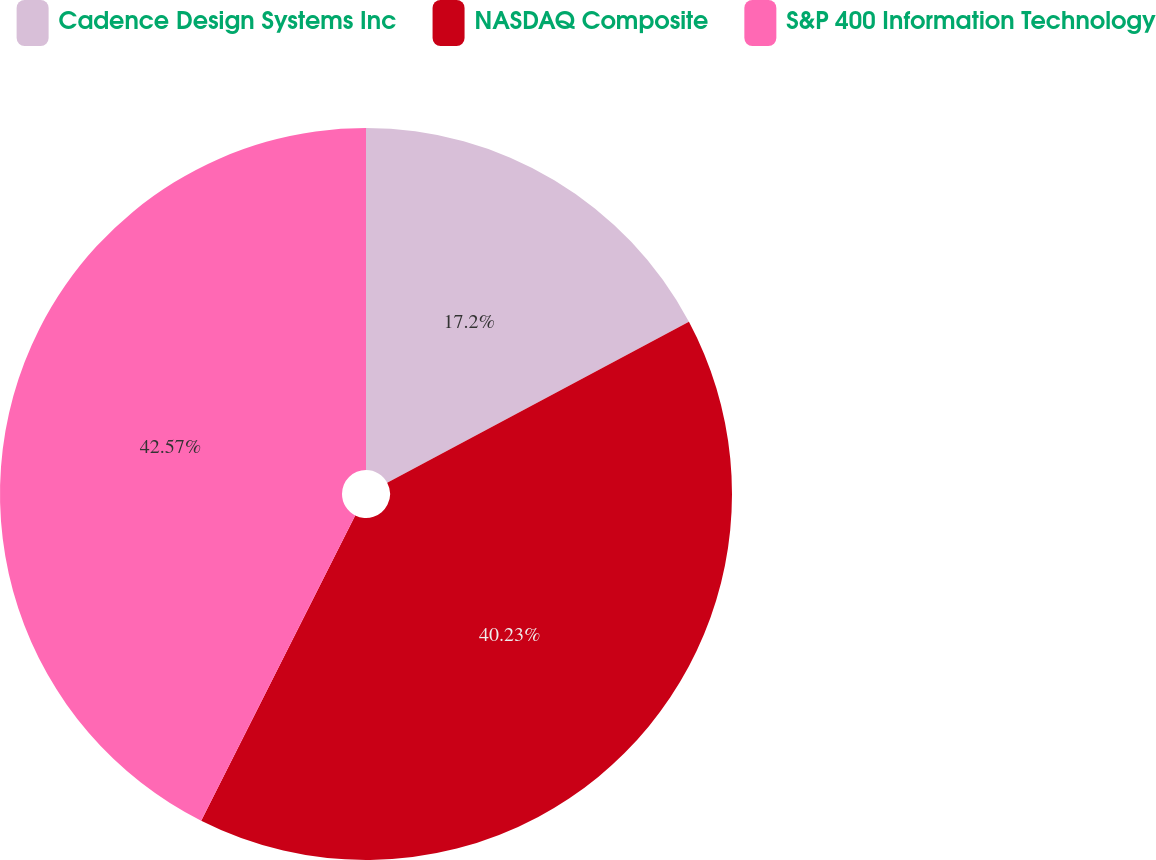Convert chart to OTSL. <chart><loc_0><loc_0><loc_500><loc_500><pie_chart><fcel>Cadence Design Systems Inc<fcel>NASDAQ Composite<fcel>S&P 400 Information Technology<nl><fcel>17.2%<fcel>40.23%<fcel>42.56%<nl></chart> 